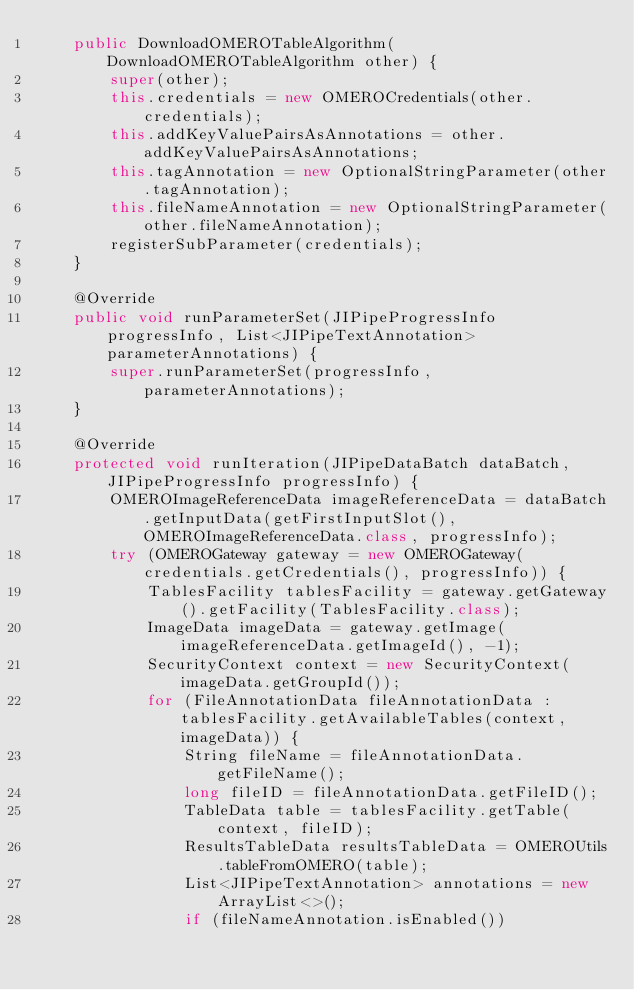Convert code to text. <code><loc_0><loc_0><loc_500><loc_500><_Java_>    public DownloadOMEROTableAlgorithm(DownloadOMEROTableAlgorithm other) {
        super(other);
        this.credentials = new OMEROCredentials(other.credentials);
        this.addKeyValuePairsAsAnnotations = other.addKeyValuePairsAsAnnotations;
        this.tagAnnotation = new OptionalStringParameter(other.tagAnnotation);
        this.fileNameAnnotation = new OptionalStringParameter(other.fileNameAnnotation);
        registerSubParameter(credentials);
    }

    @Override
    public void runParameterSet(JIPipeProgressInfo progressInfo, List<JIPipeTextAnnotation> parameterAnnotations) {
        super.runParameterSet(progressInfo, parameterAnnotations);
    }

    @Override
    protected void runIteration(JIPipeDataBatch dataBatch, JIPipeProgressInfo progressInfo) {
        OMEROImageReferenceData imageReferenceData = dataBatch.getInputData(getFirstInputSlot(), OMEROImageReferenceData.class, progressInfo);
        try (OMEROGateway gateway = new OMEROGateway(credentials.getCredentials(), progressInfo)) {
            TablesFacility tablesFacility = gateway.getGateway().getFacility(TablesFacility.class);
            ImageData imageData = gateway.getImage(imageReferenceData.getImageId(), -1);
            SecurityContext context = new SecurityContext(imageData.getGroupId());
            for (FileAnnotationData fileAnnotationData : tablesFacility.getAvailableTables(context, imageData)) {
                String fileName = fileAnnotationData.getFileName();
                long fileID = fileAnnotationData.getFileID();
                TableData table = tablesFacility.getTable(context, fileID);
                ResultsTableData resultsTableData = OMEROUtils.tableFromOMERO(table);
                List<JIPipeTextAnnotation> annotations = new ArrayList<>();
                if (fileNameAnnotation.isEnabled())</code> 